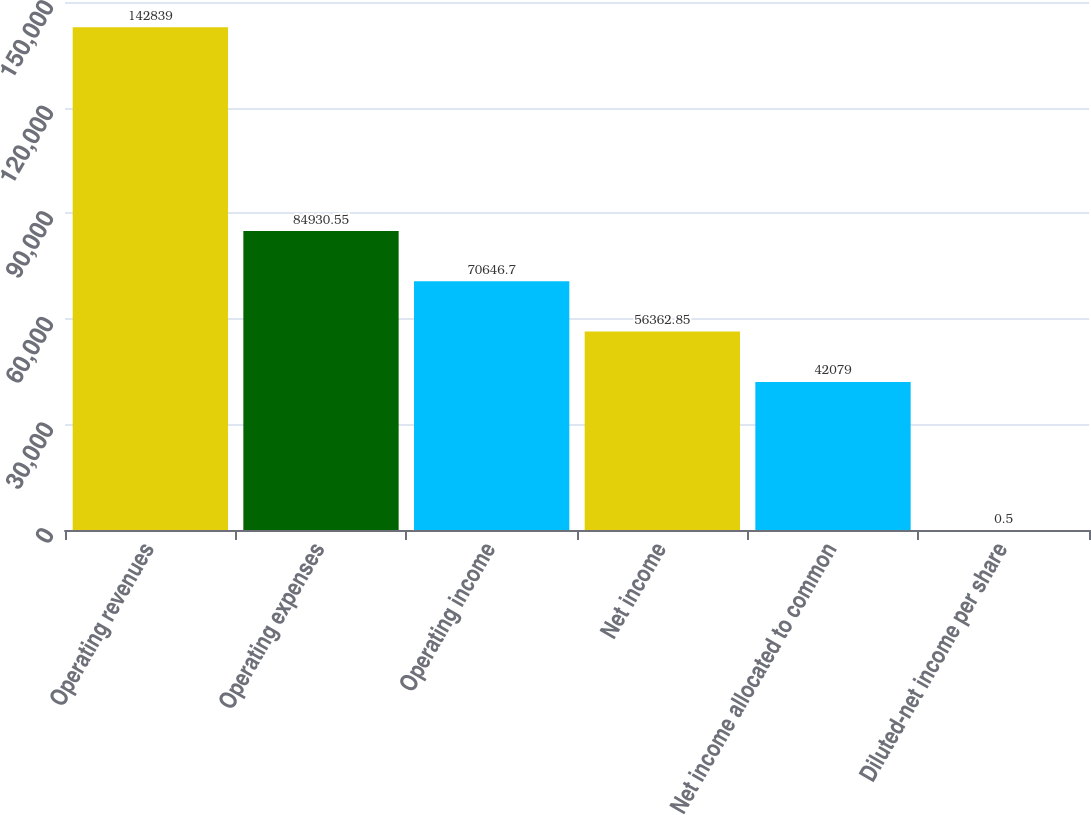Convert chart to OTSL. <chart><loc_0><loc_0><loc_500><loc_500><bar_chart><fcel>Operating revenues<fcel>Operating expenses<fcel>Operating income<fcel>Net income<fcel>Net income allocated to common<fcel>Diluted-net income per share<nl><fcel>142839<fcel>84930.6<fcel>70646.7<fcel>56362.8<fcel>42079<fcel>0.5<nl></chart> 